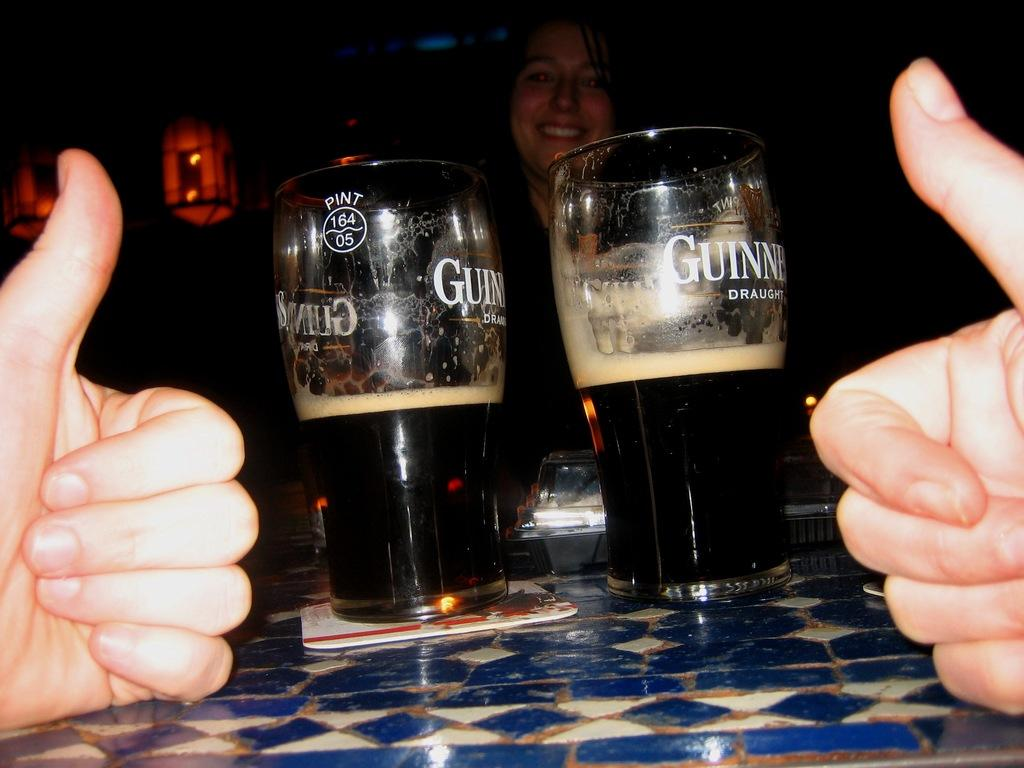Provide a one-sentence caption for the provided image. Two half full glasses of Guinness ale sit on a table. 